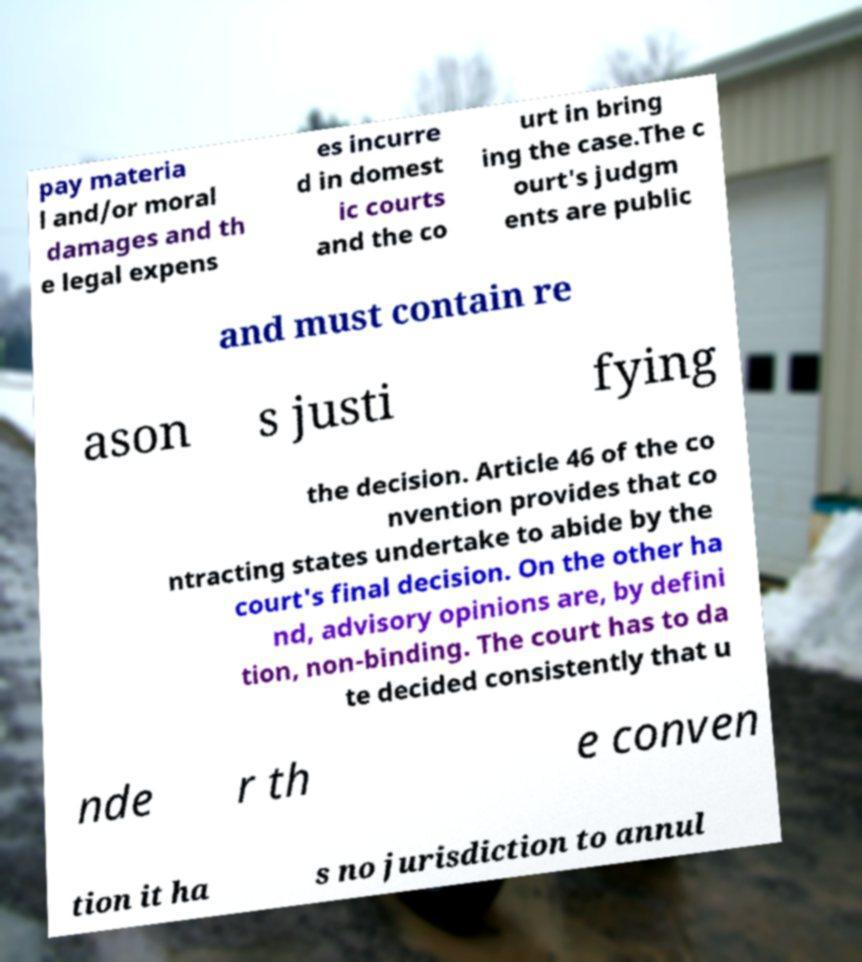Please identify and transcribe the text found in this image. pay materia l and/or moral damages and th e legal expens es incurre d in domest ic courts and the co urt in bring ing the case.The c ourt's judgm ents are public and must contain re ason s justi fying the decision. Article 46 of the co nvention provides that co ntracting states undertake to abide by the court's final decision. On the other ha nd, advisory opinions are, by defini tion, non-binding. The court has to da te decided consistently that u nde r th e conven tion it ha s no jurisdiction to annul 